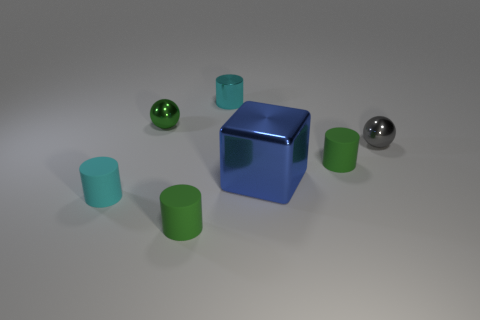Subtract 1 cylinders. How many cylinders are left? 3 Add 3 small purple metal cubes. How many objects exist? 10 Subtract all spheres. How many objects are left? 5 Add 2 tiny spheres. How many tiny spheres exist? 4 Subtract 0 brown cubes. How many objects are left? 7 Subtract all big gray cubes. Subtract all gray spheres. How many objects are left? 6 Add 5 green matte things. How many green matte things are left? 7 